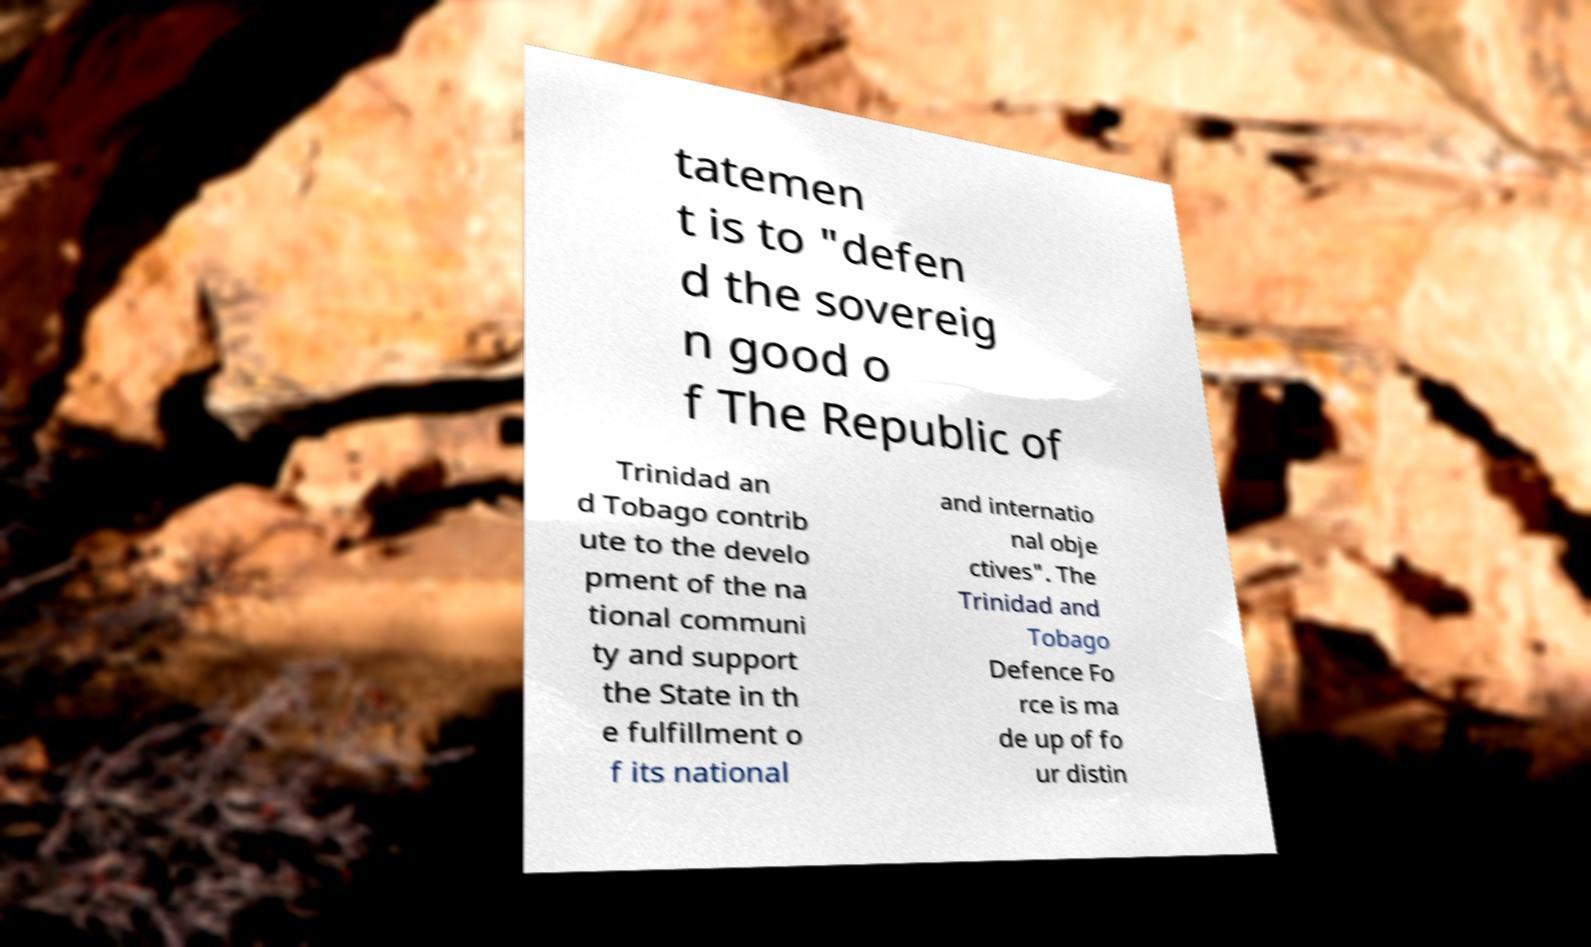For documentation purposes, I need the text within this image transcribed. Could you provide that? tatemen t is to "defen d the sovereig n good o f The Republic of Trinidad an d Tobago contrib ute to the develo pment of the na tional communi ty and support the State in th e fulfillment o f its national and internatio nal obje ctives". The Trinidad and Tobago Defence Fo rce is ma de up of fo ur distin 